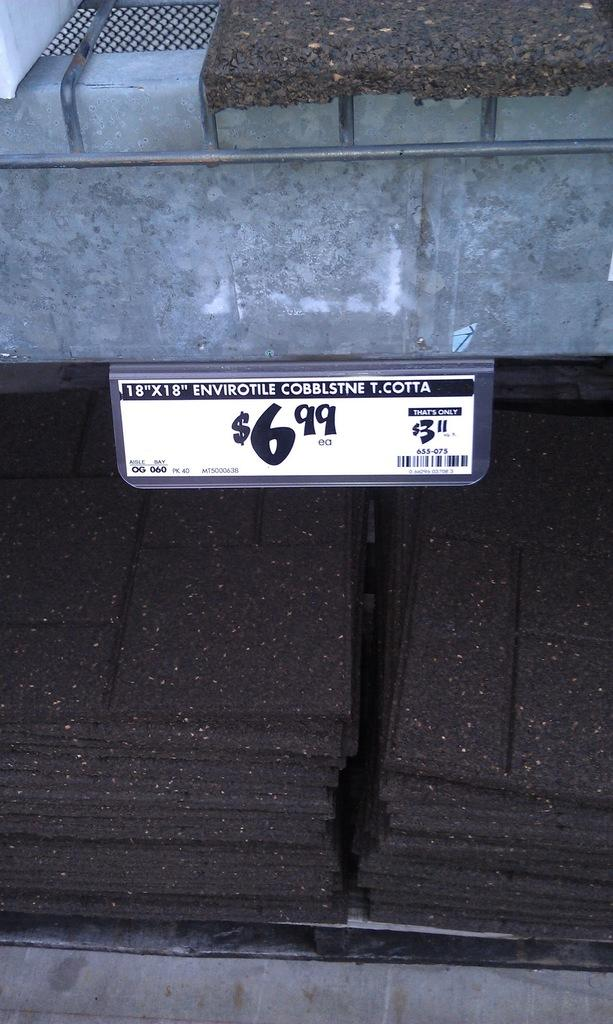What is the shape and color of the objects in the image? The objects in the image are rectangular and black in color. How are the black objects arranged in the image? The black objects are arranged in a rack. Is there any indication of the cost or value of the objects in the image? Yes, there is a price tag in the image. Can you tell me what type of pot is being used by the doctor in the image? There is no pot or doctor present in the image. What caused the objects to burst in the image? There is no indication of any objects bursting in the image. 